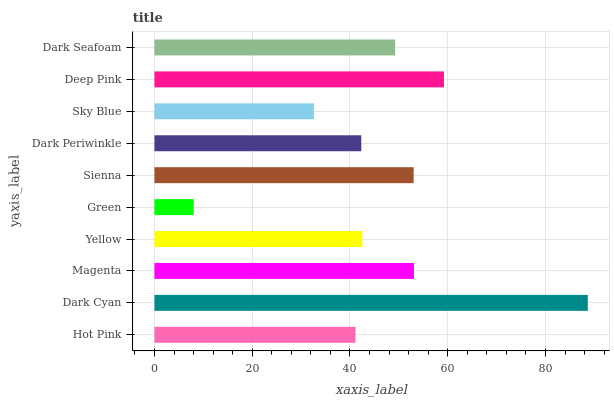Is Green the minimum?
Answer yes or no. Yes. Is Dark Cyan the maximum?
Answer yes or no. Yes. Is Magenta the minimum?
Answer yes or no. No. Is Magenta the maximum?
Answer yes or no. No. Is Dark Cyan greater than Magenta?
Answer yes or no. Yes. Is Magenta less than Dark Cyan?
Answer yes or no. Yes. Is Magenta greater than Dark Cyan?
Answer yes or no. No. Is Dark Cyan less than Magenta?
Answer yes or no. No. Is Dark Seafoam the high median?
Answer yes or no. Yes. Is Yellow the low median?
Answer yes or no. Yes. Is Deep Pink the high median?
Answer yes or no. No. Is Dark Cyan the low median?
Answer yes or no. No. 